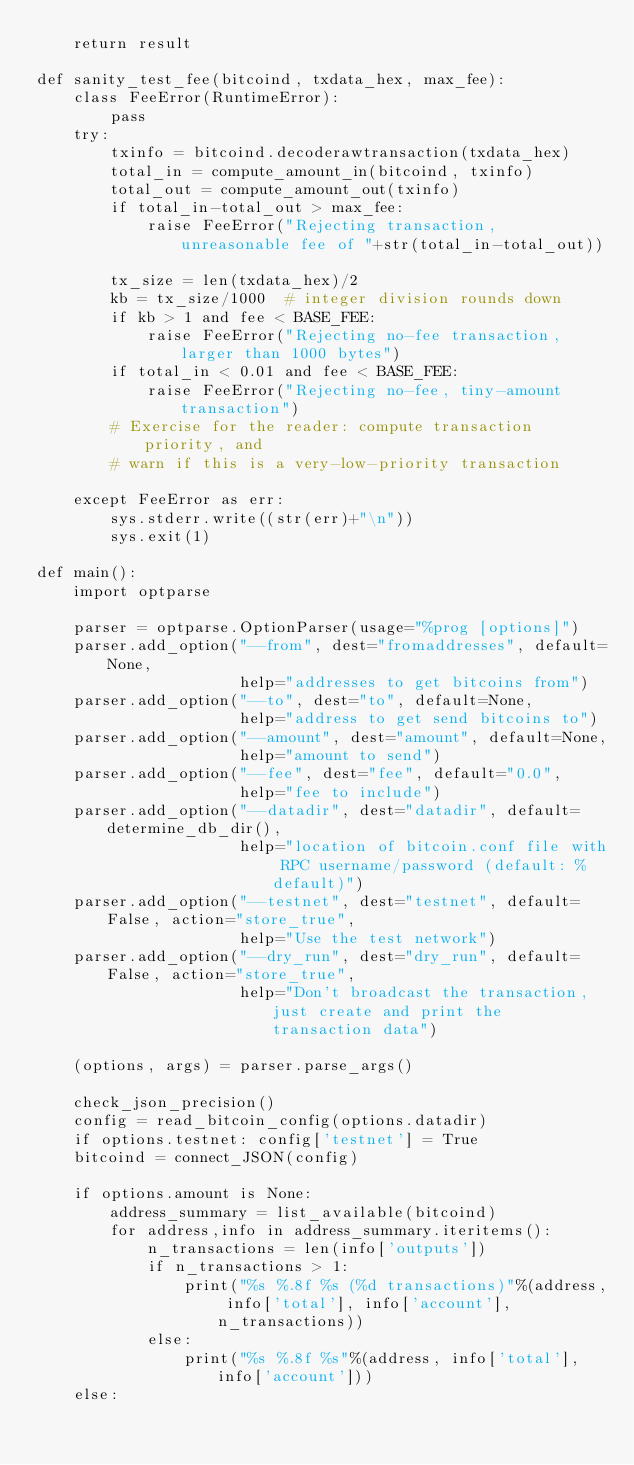Convert code to text. <code><loc_0><loc_0><loc_500><loc_500><_Python_>    return result

def sanity_test_fee(bitcoind, txdata_hex, max_fee):
    class FeeError(RuntimeError):
        pass
    try:
        txinfo = bitcoind.decoderawtransaction(txdata_hex)
        total_in = compute_amount_in(bitcoind, txinfo)
        total_out = compute_amount_out(txinfo)
        if total_in-total_out > max_fee:
            raise FeeError("Rejecting transaction, unreasonable fee of "+str(total_in-total_out))

        tx_size = len(txdata_hex)/2
        kb = tx_size/1000  # integer division rounds down
        if kb > 1 and fee < BASE_FEE:
            raise FeeError("Rejecting no-fee transaction, larger than 1000 bytes")
        if total_in < 0.01 and fee < BASE_FEE:
            raise FeeError("Rejecting no-fee, tiny-amount transaction")
        # Exercise for the reader: compute transaction priority, and
        # warn if this is a very-low-priority transaction

    except FeeError as err:
        sys.stderr.write((str(err)+"\n"))
        sys.exit(1)

def main():
    import optparse

    parser = optparse.OptionParser(usage="%prog [options]")
    parser.add_option("--from", dest="fromaddresses", default=None,
                      help="addresses to get bitcoins from")
    parser.add_option("--to", dest="to", default=None,
                      help="address to get send bitcoins to")
    parser.add_option("--amount", dest="amount", default=None,
                      help="amount to send")
    parser.add_option("--fee", dest="fee", default="0.0",
                      help="fee to include")
    parser.add_option("--datadir", dest="datadir", default=determine_db_dir(),
                      help="location of bitcoin.conf file with RPC username/password (default: %default)")
    parser.add_option("--testnet", dest="testnet", default=False, action="store_true",
                      help="Use the test network")
    parser.add_option("--dry_run", dest="dry_run", default=False, action="store_true",
                      help="Don't broadcast the transaction, just create and print the transaction data")

    (options, args) = parser.parse_args()

    check_json_precision()
    config = read_bitcoin_config(options.datadir)
    if options.testnet: config['testnet'] = True
    bitcoind = connect_JSON(config)

    if options.amount is None:
        address_summary = list_available(bitcoind)
        for address,info in address_summary.iteritems():
            n_transactions = len(info['outputs'])
            if n_transactions > 1:
                print("%s %.8f %s (%d transactions)"%(address, info['total'], info['account'], n_transactions))
            else:
                print("%s %.8f %s"%(address, info['total'], info['account']))
    else:</code> 